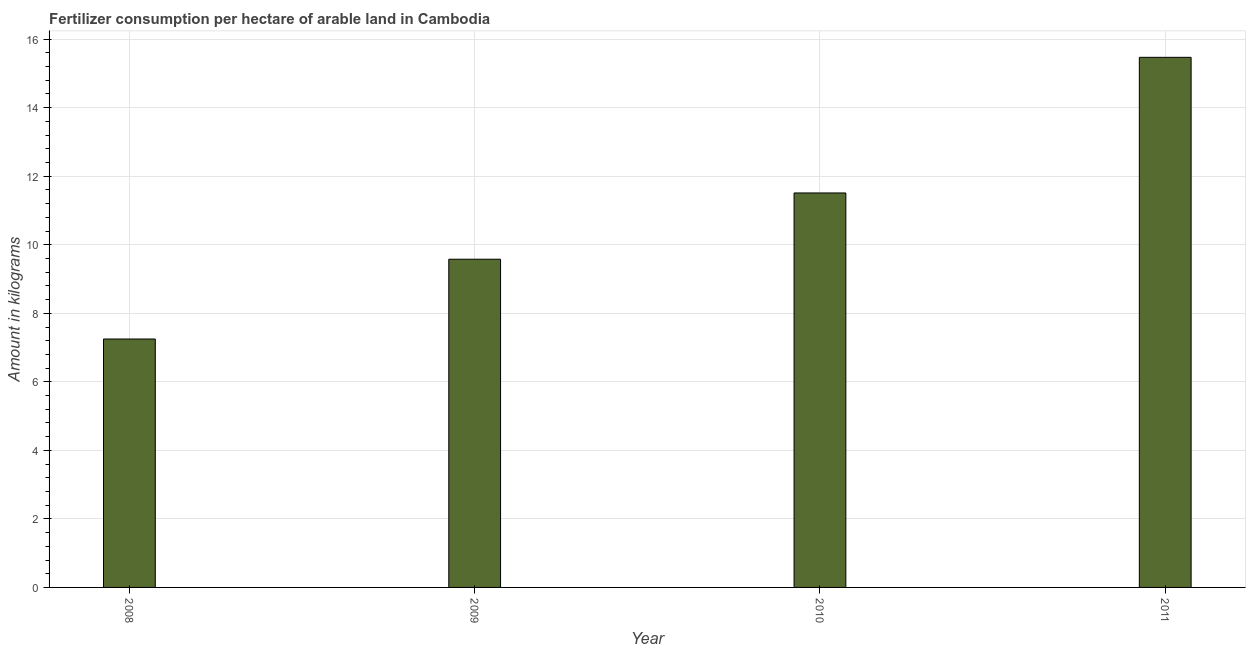Does the graph contain any zero values?
Your answer should be compact. No. Does the graph contain grids?
Provide a succinct answer. Yes. What is the title of the graph?
Provide a short and direct response. Fertilizer consumption per hectare of arable land in Cambodia . What is the label or title of the Y-axis?
Make the answer very short. Amount in kilograms. What is the amount of fertilizer consumption in 2009?
Your response must be concise. 9.58. Across all years, what is the maximum amount of fertilizer consumption?
Offer a terse response. 15.47. Across all years, what is the minimum amount of fertilizer consumption?
Provide a short and direct response. 7.25. In which year was the amount of fertilizer consumption maximum?
Keep it short and to the point. 2011. In which year was the amount of fertilizer consumption minimum?
Make the answer very short. 2008. What is the sum of the amount of fertilizer consumption?
Give a very brief answer. 43.81. What is the difference between the amount of fertilizer consumption in 2008 and 2011?
Make the answer very short. -8.22. What is the average amount of fertilizer consumption per year?
Your answer should be very brief. 10.95. What is the median amount of fertilizer consumption?
Your answer should be very brief. 10.54. What is the ratio of the amount of fertilizer consumption in 2010 to that in 2011?
Make the answer very short. 0.74. Is the difference between the amount of fertilizer consumption in 2009 and 2010 greater than the difference between any two years?
Your response must be concise. No. What is the difference between the highest and the second highest amount of fertilizer consumption?
Offer a very short reply. 3.96. Is the sum of the amount of fertilizer consumption in 2008 and 2010 greater than the maximum amount of fertilizer consumption across all years?
Ensure brevity in your answer.  Yes. What is the difference between the highest and the lowest amount of fertilizer consumption?
Ensure brevity in your answer.  8.22. How many bars are there?
Offer a terse response. 4. Are all the bars in the graph horizontal?
Provide a short and direct response. No. How many years are there in the graph?
Ensure brevity in your answer.  4. What is the Amount in kilograms of 2008?
Give a very brief answer. 7.25. What is the Amount in kilograms in 2009?
Your response must be concise. 9.58. What is the Amount in kilograms of 2010?
Ensure brevity in your answer.  11.51. What is the Amount in kilograms in 2011?
Provide a succinct answer. 15.47. What is the difference between the Amount in kilograms in 2008 and 2009?
Offer a very short reply. -2.33. What is the difference between the Amount in kilograms in 2008 and 2010?
Provide a short and direct response. -4.26. What is the difference between the Amount in kilograms in 2008 and 2011?
Your response must be concise. -8.22. What is the difference between the Amount in kilograms in 2009 and 2010?
Offer a terse response. -1.93. What is the difference between the Amount in kilograms in 2009 and 2011?
Your response must be concise. -5.89. What is the difference between the Amount in kilograms in 2010 and 2011?
Provide a short and direct response. -3.96. What is the ratio of the Amount in kilograms in 2008 to that in 2009?
Your response must be concise. 0.76. What is the ratio of the Amount in kilograms in 2008 to that in 2010?
Make the answer very short. 0.63. What is the ratio of the Amount in kilograms in 2008 to that in 2011?
Your answer should be compact. 0.47. What is the ratio of the Amount in kilograms in 2009 to that in 2010?
Provide a short and direct response. 0.83. What is the ratio of the Amount in kilograms in 2009 to that in 2011?
Make the answer very short. 0.62. What is the ratio of the Amount in kilograms in 2010 to that in 2011?
Offer a terse response. 0.74. 